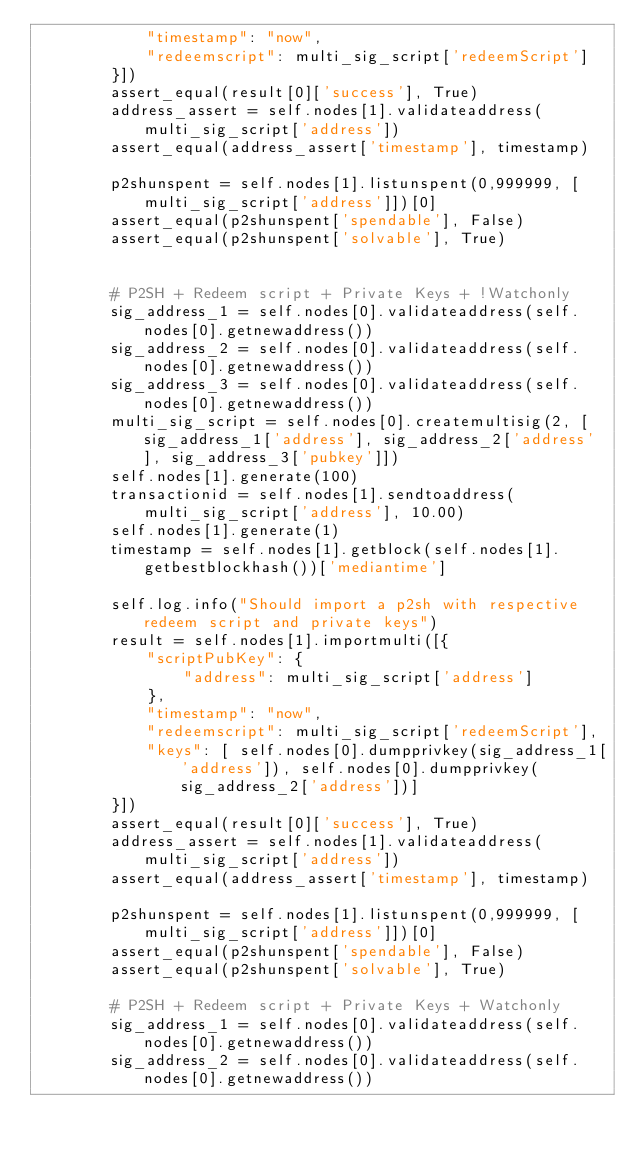Convert code to text. <code><loc_0><loc_0><loc_500><loc_500><_Python_>            "timestamp": "now",
            "redeemscript": multi_sig_script['redeemScript']
        }])
        assert_equal(result[0]['success'], True)
        address_assert = self.nodes[1].validateaddress(multi_sig_script['address'])
        assert_equal(address_assert['timestamp'], timestamp)

        p2shunspent = self.nodes[1].listunspent(0,999999, [multi_sig_script['address']])[0]
        assert_equal(p2shunspent['spendable'], False)
        assert_equal(p2shunspent['solvable'], True)


        # P2SH + Redeem script + Private Keys + !Watchonly
        sig_address_1 = self.nodes[0].validateaddress(self.nodes[0].getnewaddress())
        sig_address_2 = self.nodes[0].validateaddress(self.nodes[0].getnewaddress())
        sig_address_3 = self.nodes[0].validateaddress(self.nodes[0].getnewaddress())
        multi_sig_script = self.nodes[0].createmultisig(2, [sig_address_1['address'], sig_address_2['address'], sig_address_3['pubkey']])
        self.nodes[1].generate(100)
        transactionid = self.nodes[1].sendtoaddress(multi_sig_script['address'], 10.00)
        self.nodes[1].generate(1)
        timestamp = self.nodes[1].getblock(self.nodes[1].getbestblockhash())['mediantime']

        self.log.info("Should import a p2sh with respective redeem script and private keys")
        result = self.nodes[1].importmulti([{
            "scriptPubKey": {
                "address": multi_sig_script['address']
            },
            "timestamp": "now",
            "redeemscript": multi_sig_script['redeemScript'],
            "keys": [ self.nodes[0].dumpprivkey(sig_address_1['address']), self.nodes[0].dumpprivkey(sig_address_2['address'])]
        }])
        assert_equal(result[0]['success'], True)
        address_assert = self.nodes[1].validateaddress(multi_sig_script['address'])
        assert_equal(address_assert['timestamp'], timestamp)

        p2shunspent = self.nodes[1].listunspent(0,999999, [multi_sig_script['address']])[0]
        assert_equal(p2shunspent['spendable'], False)
        assert_equal(p2shunspent['solvable'], True)

        # P2SH + Redeem script + Private Keys + Watchonly
        sig_address_1 = self.nodes[0].validateaddress(self.nodes[0].getnewaddress())
        sig_address_2 = self.nodes[0].validateaddress(self.nodes[0].getnewaddress())</code> 